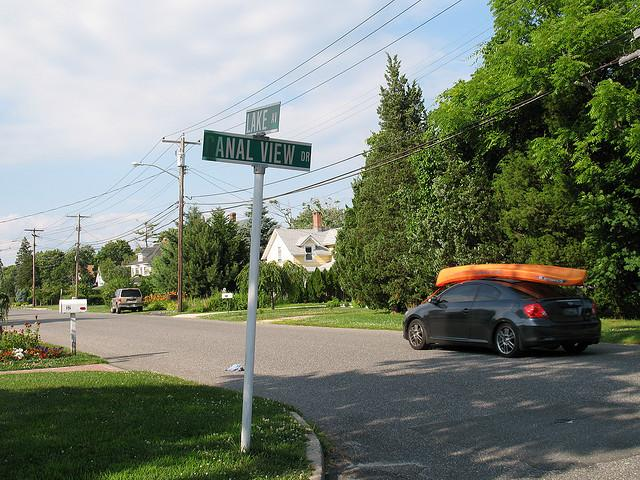What type of tool do you need to move while in the object on top of the black car? Please explain your reasoning. paddle. You will need a paddle to row the boat. 